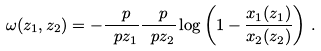Convert formula to latex. <formula><loc_0><loc_0><loc_500><loc_500>\omega ( z _ { 1 } , z _ { 2 } ) = - \frac { \ p } { \ p z _ { 1 } } \frac { \ p } { \ p z _ { 2 } } \log \left ( 1 - \frac { x _ { 1 } ( z _ { 1 } ) } { x _ { 2 } ( z _ { 2 } ) } \right ) \, .</formula> 